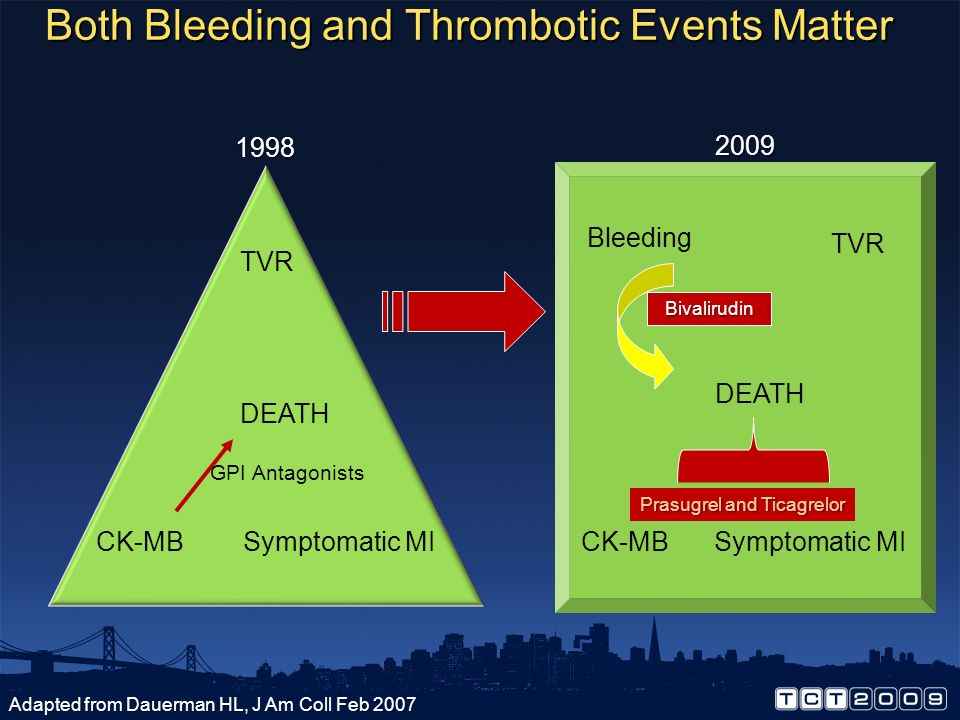Based on this image, what realistic medical goals might have been set for 2020? Based on this image, by 2020, medical goals likely focused on further integrating bleeding risk management alongside thrombotic event prevention in cardiovascular treatments. Achieving optimal balance with minimal side effects, improving overall patient outcomes, and tailoring treatments to individual patient profiles using precision medicine may have been prioritized. Additionally, there might have been efforts to advance pharmacological innovations beyond Bivalirudin, Prasugrel, and Ticagrelor, and to further decrease the rates of TVR (Target Vessel Revascularization) and mortality. Enhanced post-procedural care protocols to monitor and swiftly address bleeding complications would also likely be critical goals. What specific therapeutic advancements could you expect to see by 2020? By 2020, specific therapeutic advancements could include the introduction of more sophisticated anticoagulants and antiplatelet drugs that offer better balance between preventing thrombosis and minimizing bleeding risks. Enhanced drug delivery systems such as biodegradable stents releasing medication directly to targeted areas, and personalized medicine approaches utilizing genetic profiling for tailored treatments, could be expected. Advances in minimally invasive surgical techniques, improved diagnostic imaging technologies, and the implementation of AI algorithms to predict and manage complications in real-time may also be seen. Moreover, increased integration of patient data management systems for continuous monitoring and individualized care plans would likely be prevalent. 